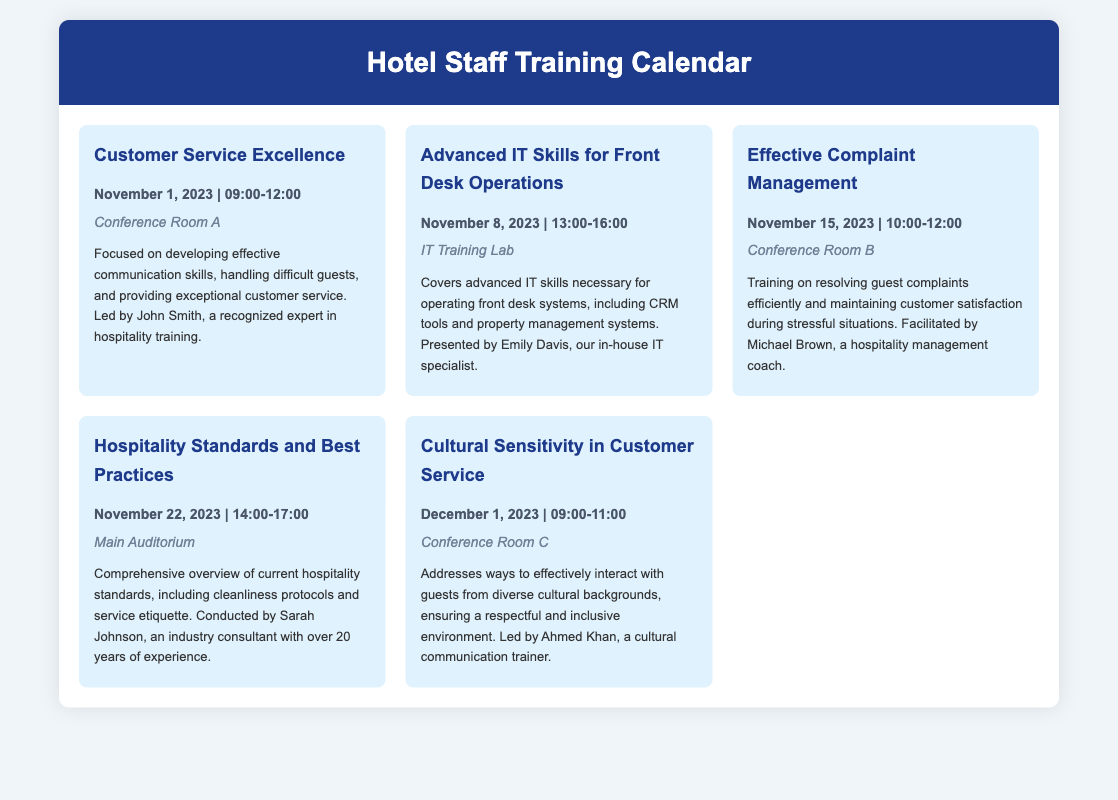what is the title of the first training session? The title of the first training session is found at the top of the first event listed.
Answer: Customer Service Excellence who is presenting the Effective Complaint Management training? The presenter is mentioned at the end of the description for that particular event.
Answer: Michael Brown how long is the Hospitality Standards and Best Practices workshop? The duration can be inferred by looking at the start and end times provided in the event details.
Answer: 3 hours in which location will the Cultural Sensitivity in Customer Service session be held? The location is specified in the details of the corresponding event.
Answer: Conference Room C what is the main topic of the final training session? The main topic can be found in the title of the last event listed in the calendar.
Answer: Cultural Sensitivity in Customer Service which workshop focuses on communication skills? The topic can be determined by reviewing the titles of the training sessions.
Answer: Customer Service Excellence how many training sessions are scheduled in total? The total number of sessions is found by counting the events listed in the calendar.
Answer: 5 